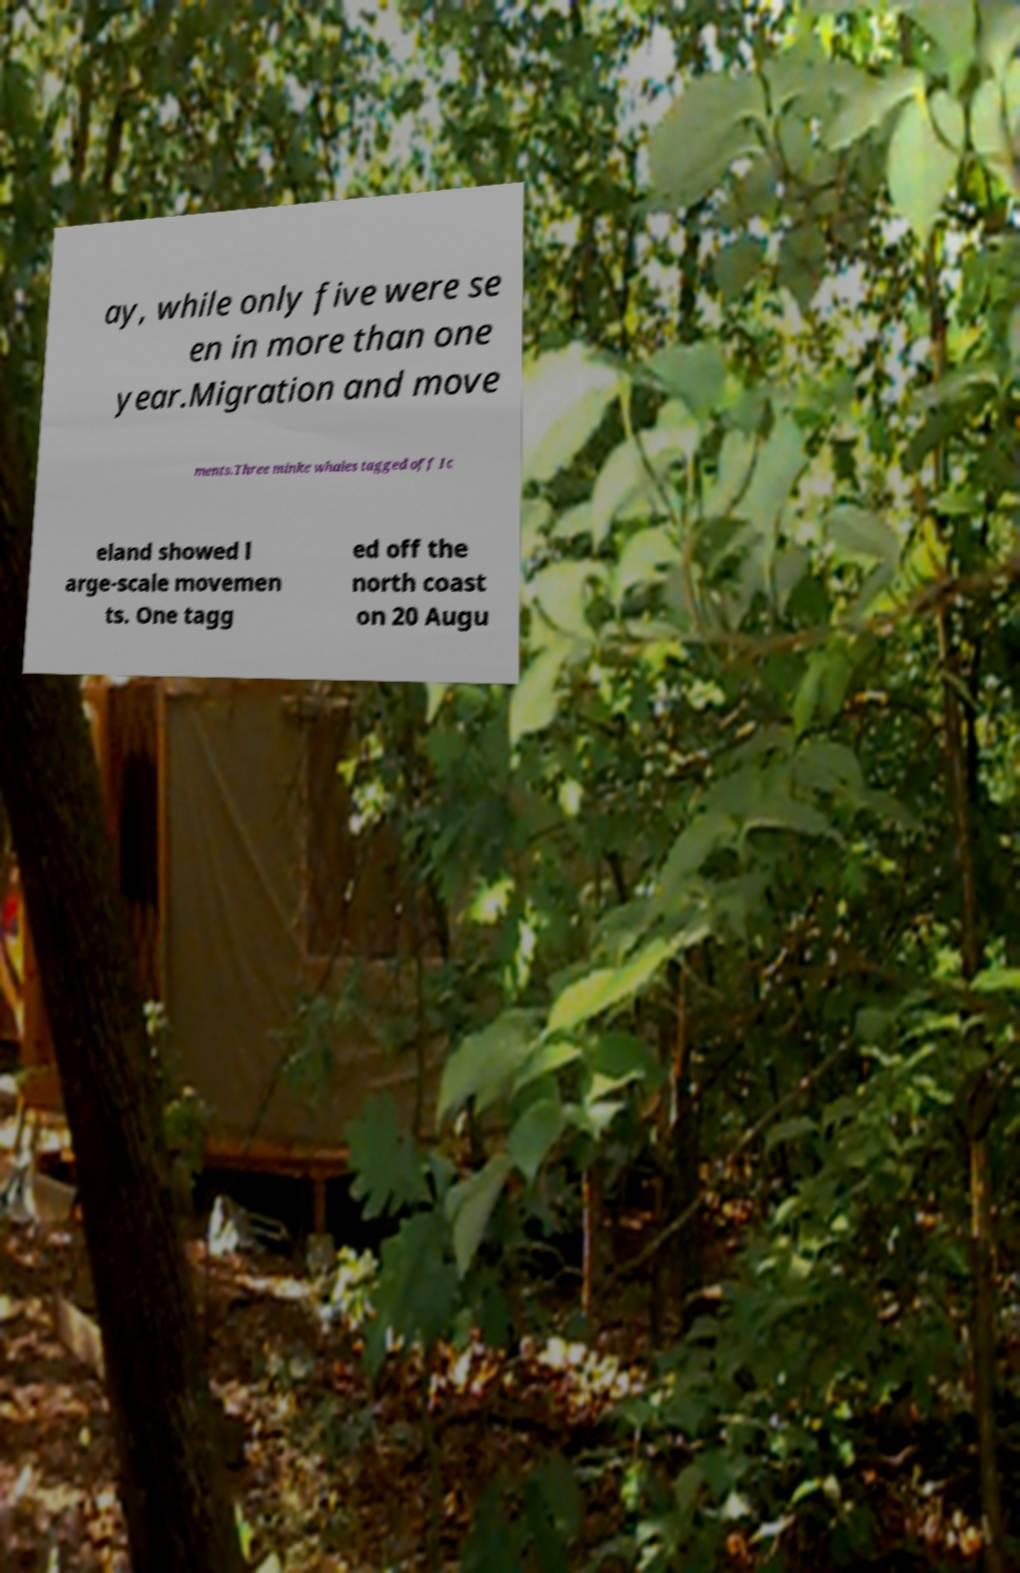Could you extract and type out the text from this image? ay, while only five were se en in more than one year.Migration and move ments.Three minke whales tagged off Ic eland showed l arge-scale movemen ts. One tagg ed off the north coast on 20 Augu 